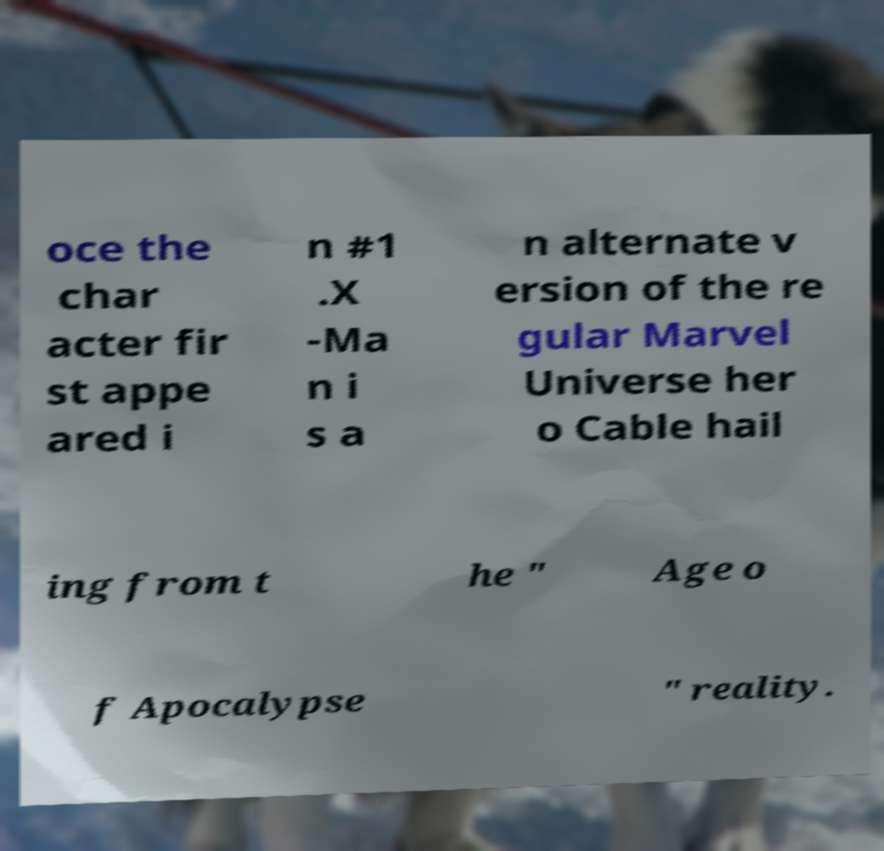I need the written content from this picture converted into text. Can you do that? oce the char acter fir st appe ared i n #1 .X -Ma n i s a n alternate v ersion of the re gular Marvel Universe her o Cable hail ing from t he " Age o f Apocalypse " reality. 